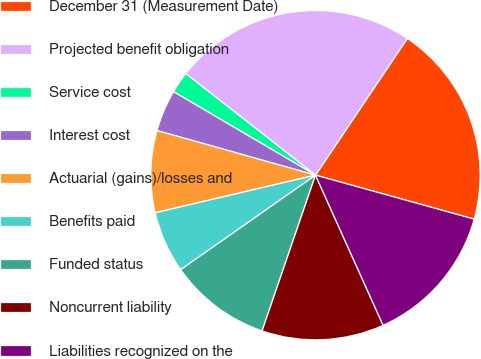Convert chart to OTSL. <chart><loc_0><loc_0><loc_500><loc_500><pie_chart><fcel>December 31 (Measurement Date)<fcel>Projected benefit obligation<fcel>Service cost<fcel>Interest cost<fcel>Actuarial (gains)/losses and<fcel>Benefits paid<fcel>Funded status<fcel>Noncurrent liability<fcel>Liabilities recognized on the<nl><fcel>19.89%<fcel>23.84%<fcel>2.11%<fcel>4.09%<fcel>8.04%<fcel>6.06%<fcel>10.01%<fcel>11.99%<fcel>13.96%<nl></chart> 